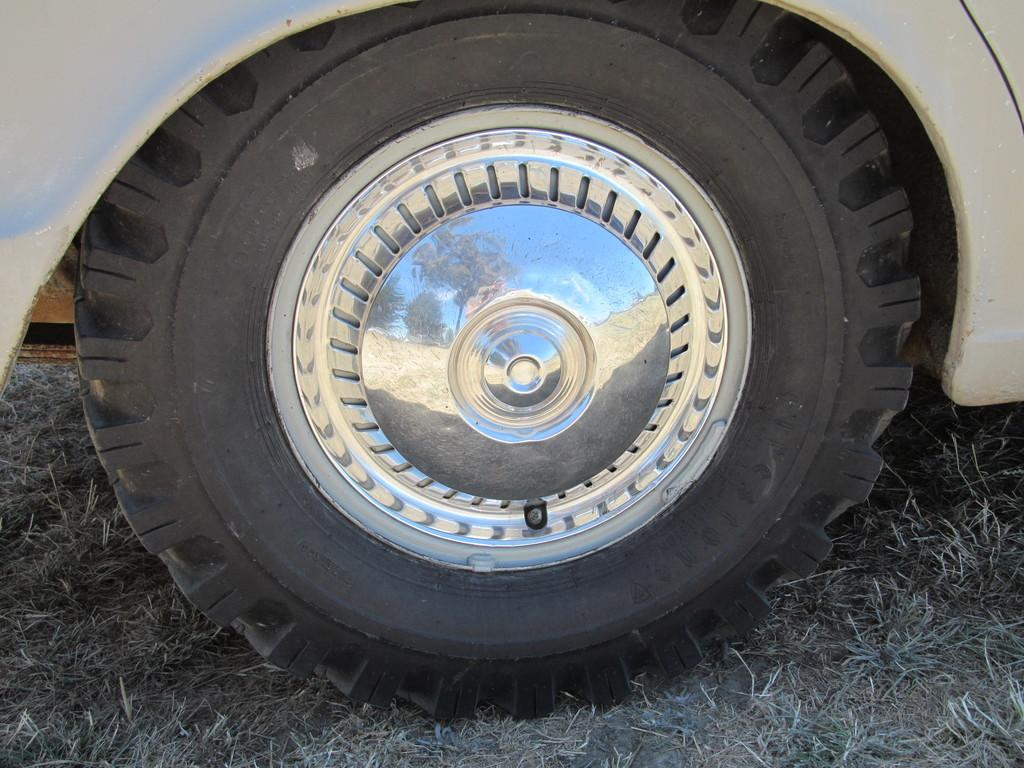What is the main subject of the image? The main subject of the image is a wheel of a vehicle. What type of material covers the wheel? The wheel has a tyre. Is there any additional feature on the wheel? Yes, the wheel has a centre cap. What type of music can be heard coming from the yard in the image? There is no yard or music present in the image; it only features a wheel with a tyre and a centre cap. 